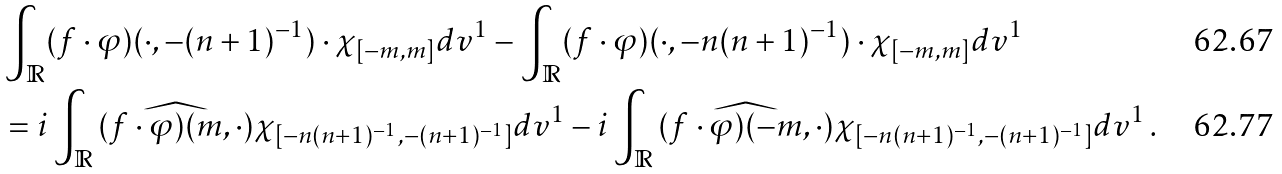Convert formula to latex. <formula><loc_0><loc_0><loc_500><loc_500>& \int _ { \mathbb { R } } ( f \cdot \varphi ) ( \cdot , - ( n + 1 ) ^ { - 1 } ) \cdot \chi _ { [ - m , m ] } d v ^ { 1 } - \int _ { \mathbb { R } } ( f \cdot \varphi ) ( \cdot , - n ( n + 1 ) ^ { - 1 } ) \cdot \chi _ { [ - m , m ] } d v ^ { 1 } \\ & = i \int _ { \mathbb { R } } \widehat { ( f \cdot \varphi ) ( m , \cdot ) } \chi _ { [ - n ( n + 1 ) ^ { - 1 } , - ( n + 1 ) ^ { - 1 } ] } d v ^ { 1 } - i \int _ { \mathbb { R } } \widehat { ( f \cdot \varphi ) ( - m , \cdot ) } \chi _ { [ - n ( n + 1 ) ^ { - 1 } , - ( n + 1 ) ^ { - 1 } ] } d v ^ { 1 } \, .</formula> 